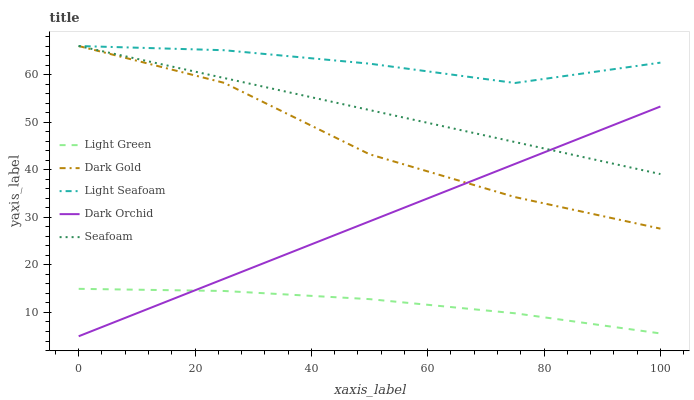Does Light Green have the minimum area under the curve?
Answer yes or no. Yes. Does Light Seafoam have the maximum area under the curve?
Answer yes or no. Yes. Does Seafoam have the minimum area under the curve?
Answer yes or no. No. Does Seafoam have the maximum area under the curve?
Answer yes or no. No. Is Seafoam the smoothest?
Answer yes or no. Yes. Is Dark Gold the roughest?
Answer yes or no. Yes. Is Dark Orchid the smoothest?
Answer yes or no. No. Is Dark Orchid the roughest?
Answer yes or no. No. Does Dark Orchid have the lowest value?
Answer yes or no. Yes. Does Seafoam have the lowest value?
Answer yes or no. No. Does Dark Gold have the highest value?
Answer yes or no. Yes. Does Dark Orchid have the highest value?
Answer yes or no. No. Is Light Green less than Seafoam?
Answer yes or no. Yes. Is Dark Gold greater than Light Green?
Answer yes or no. Yes. Does Dark Orchid intersect Light Green?
Answer yes or no. Yes. Is Dark Orchid less than Light Green?
Answer yes or no. No. Is Dark Orchid greater than Light Green?
Answer yes or no. No. Does Light Green intersect Seafoam?
Answer yes or no. No. 